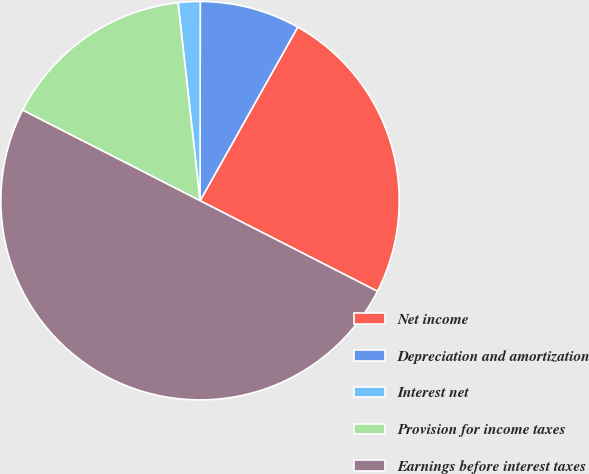Convert chart. <chart><loc_0><loc_0><loc_500><loc_500><pie_chart><fcel>Net income<fcel>Depreciation and amortization<fcel>Interest net<fcel>Provision for income taxes<fcel>Earnings before interest taxes<nl><fcel>24.36%<fcel>8.14%<fcel>1.78%<fcel>15.73%<fcel>50.0%<nl></chart> 